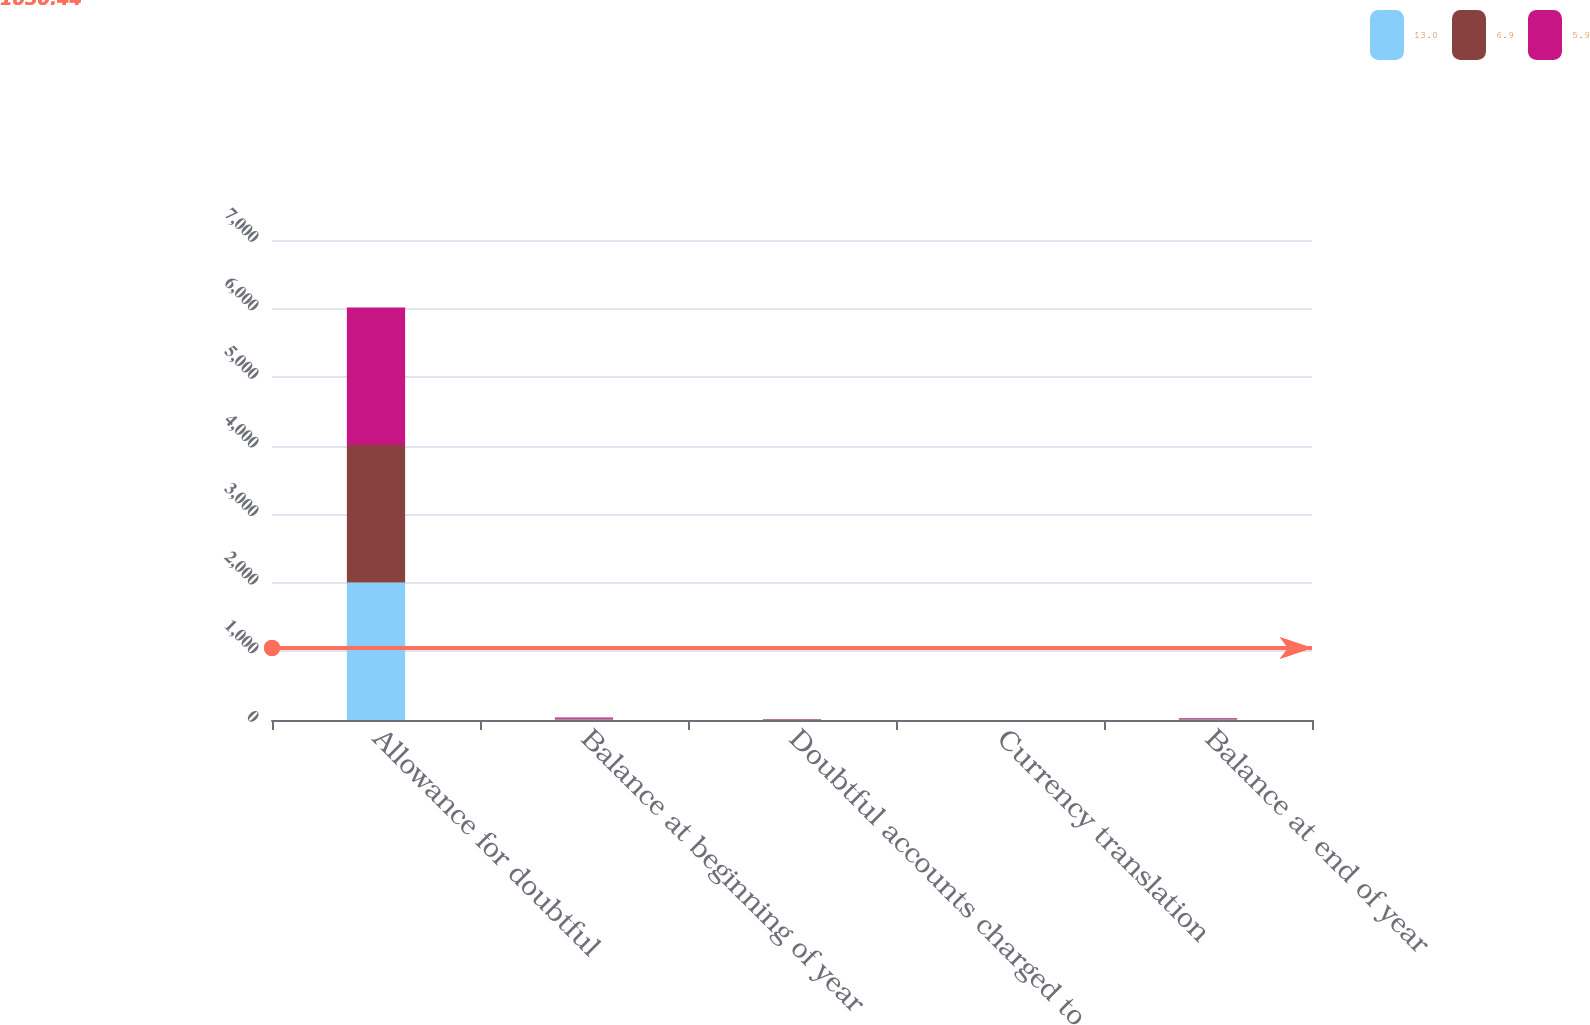<chart> <loc_0><loc_0><loc_500><loc_500><stacked_bar_chart><ecel><fcel>Allowance for doubtful<fcel>Balance at beginning of year<fcel>Doubtful accounts charged to<fcel>Currency translation<fcel>Balance at end of year<nl><fcel>13<fcel>2006<fcel>6.9<fcel>2.8<fcel>0.2<fcel>5.9<nl><fcel>6.9<fcel>2005<fcel>13<fcel>7.4<fcel>1.3<fcel>6.9<nl><fcel>5.9<fcel>2004<fcel>15.1<fcel>4.3<fcel>0.1<fcel>13<nl></chart> 